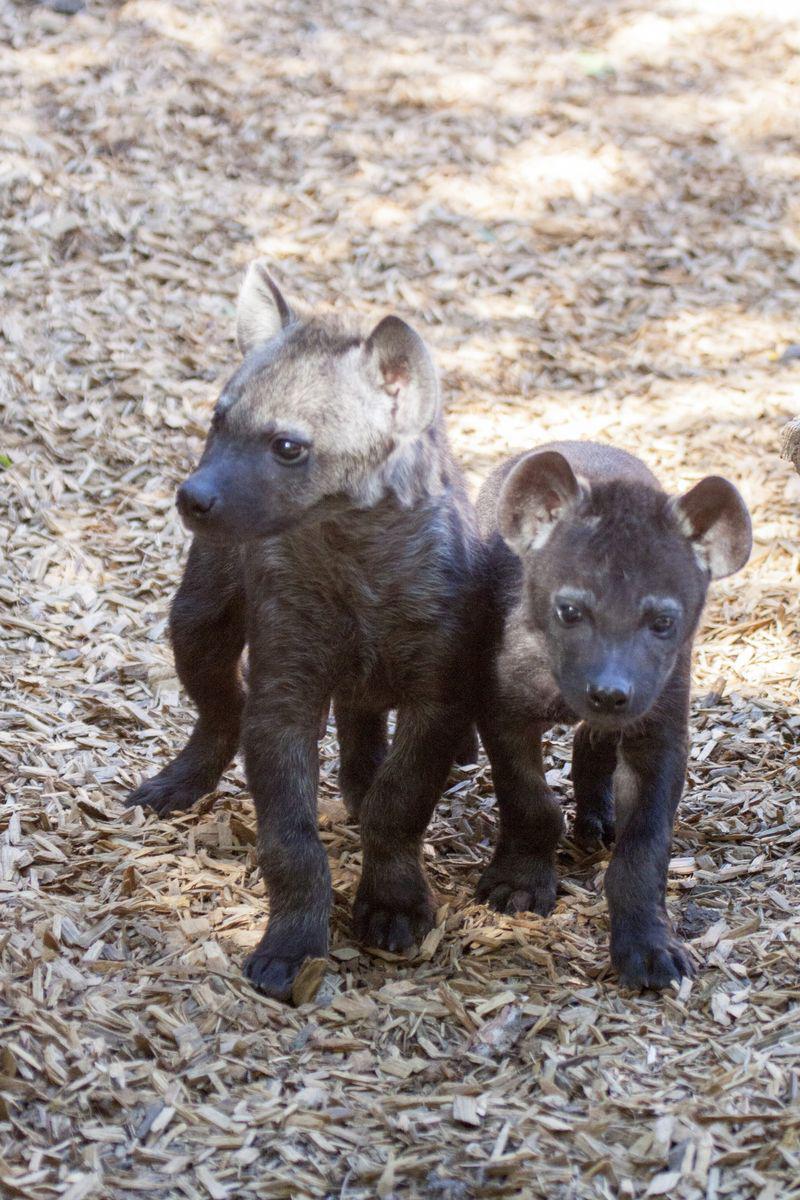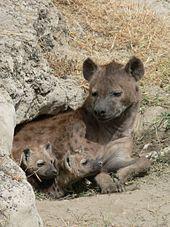The first image is the image on the left, the second image is the image on the right. For the images displayed, is the sentence "The right image contains exactly two hyenas." factually correct? Answer yes or no. No. The first image is the image on the left, the second image is the image on the right. Assess this claim about the two images: "One image includes a dark hyena pup and an adult hyena, and shows their heads one above the other.". Correct or not? Answer yes or no. No. 